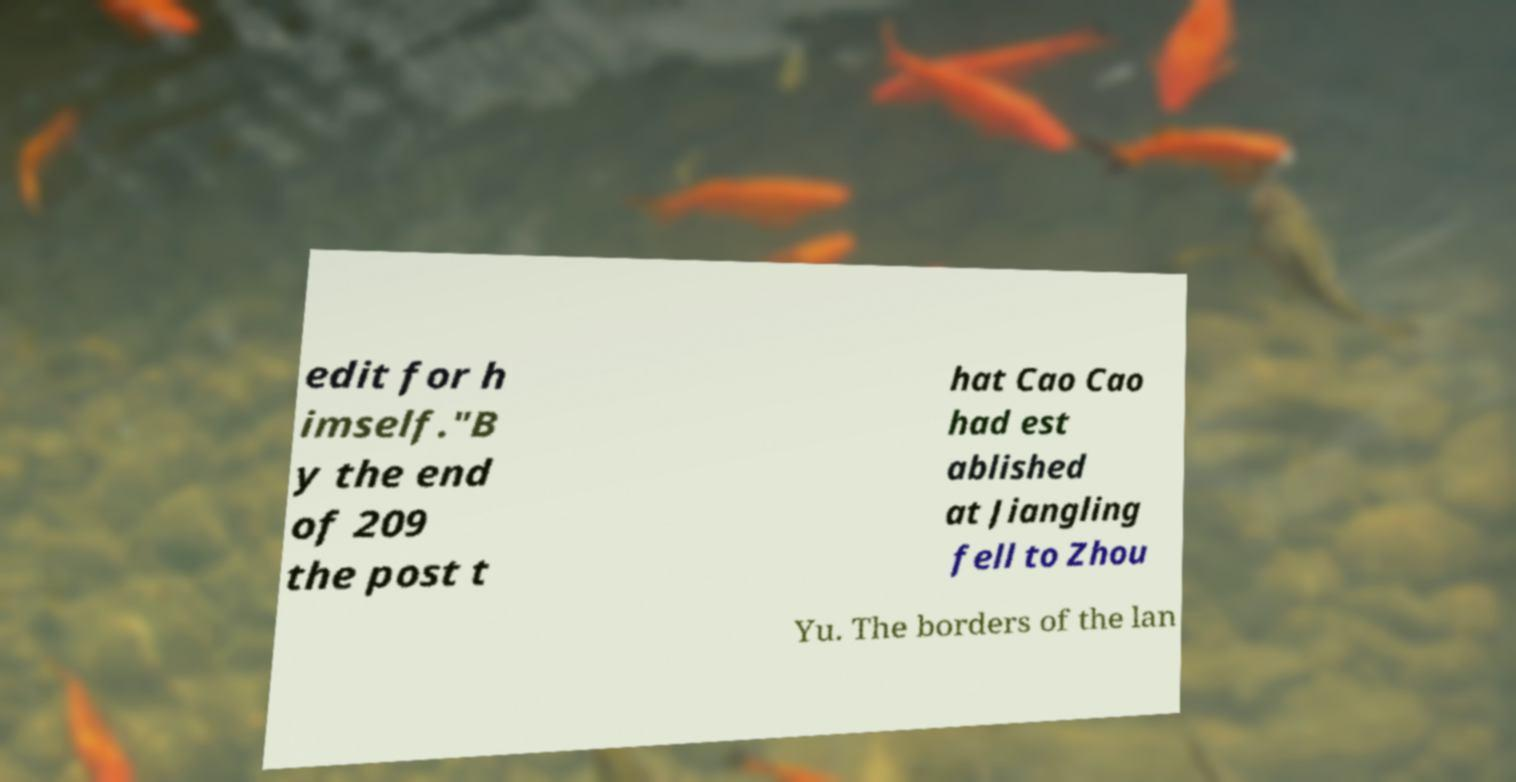Please identify and transcribe the text found in this image. edit for h imself."B y the end of 209 the post t hat Cao Cao had est ablished at Jiangling fell to Zhou Yu. The borders of the lan 